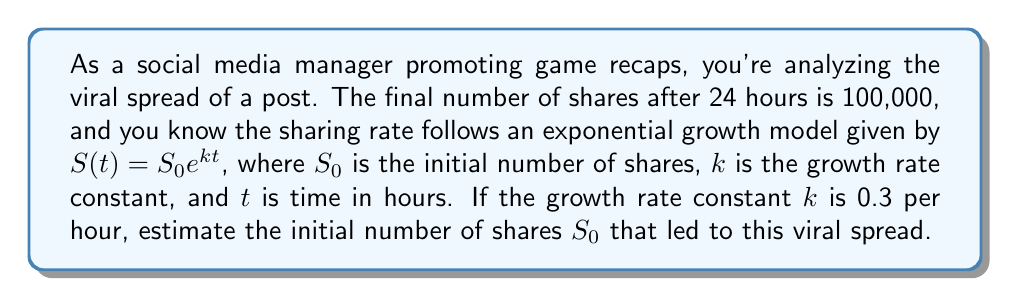Can you answer this question? To solve this inverse problem, we need to work backwards from the final state to determine the initial conditions. Let's approach this step-by-step:

1) We're given the exponential growth model:
   $$S(t) = S_0 e^{kt}$$

2) We know the following:
   - Final number of shares, $S(24) = 100,000$
   - Time, $t = 24$ hours
   - Growth rate constant, $k = 0.3$ per hour

3) Let's substitute these values into our equation:
   $$100,000 = S_0 e^{0.3 \cdot 24}$$

4) Simplify the exponent:
   $$100,000 = S_0 e^{7.2}$$

5) Calculate $e^{7.2}$:
   $$100,000 = S_0 \cdot 1,339.43$$

6) Solve for $S_0$ by dividing both sides by 1,339.43:
   $$S_0 = \frac{100,000}{1,339.43} \approx 74.66$$

7) Since we're dealing with shares, we need to round to the nearest whole number:
   $$S_0 \approx 75$$

Therefore, the estimated initial number of shares that led to this viral spread is approximately 75.
Answer: 75 shares 